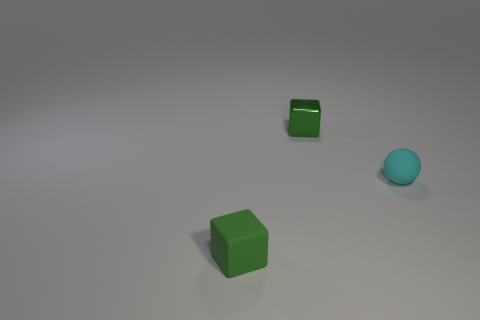Add 2 green shiny blocks. How many objects exist? 5 Subtract all spheres. How many objects are left? 2 Subtract 1 balls. How many balls are left? 0 Subtract all tiny things. Subtract all large green matte blocks. How many objects are left? 0 Add 1 cyan objects. How many cyan objects are left? 2 Add 2 big purple objects. How many big purple objects exist? 2 Subtract 2 green blocks. How many objects are left? 1 Subtract all red cubes. Subtract all yellow spheres. How many cubes are left? 2 